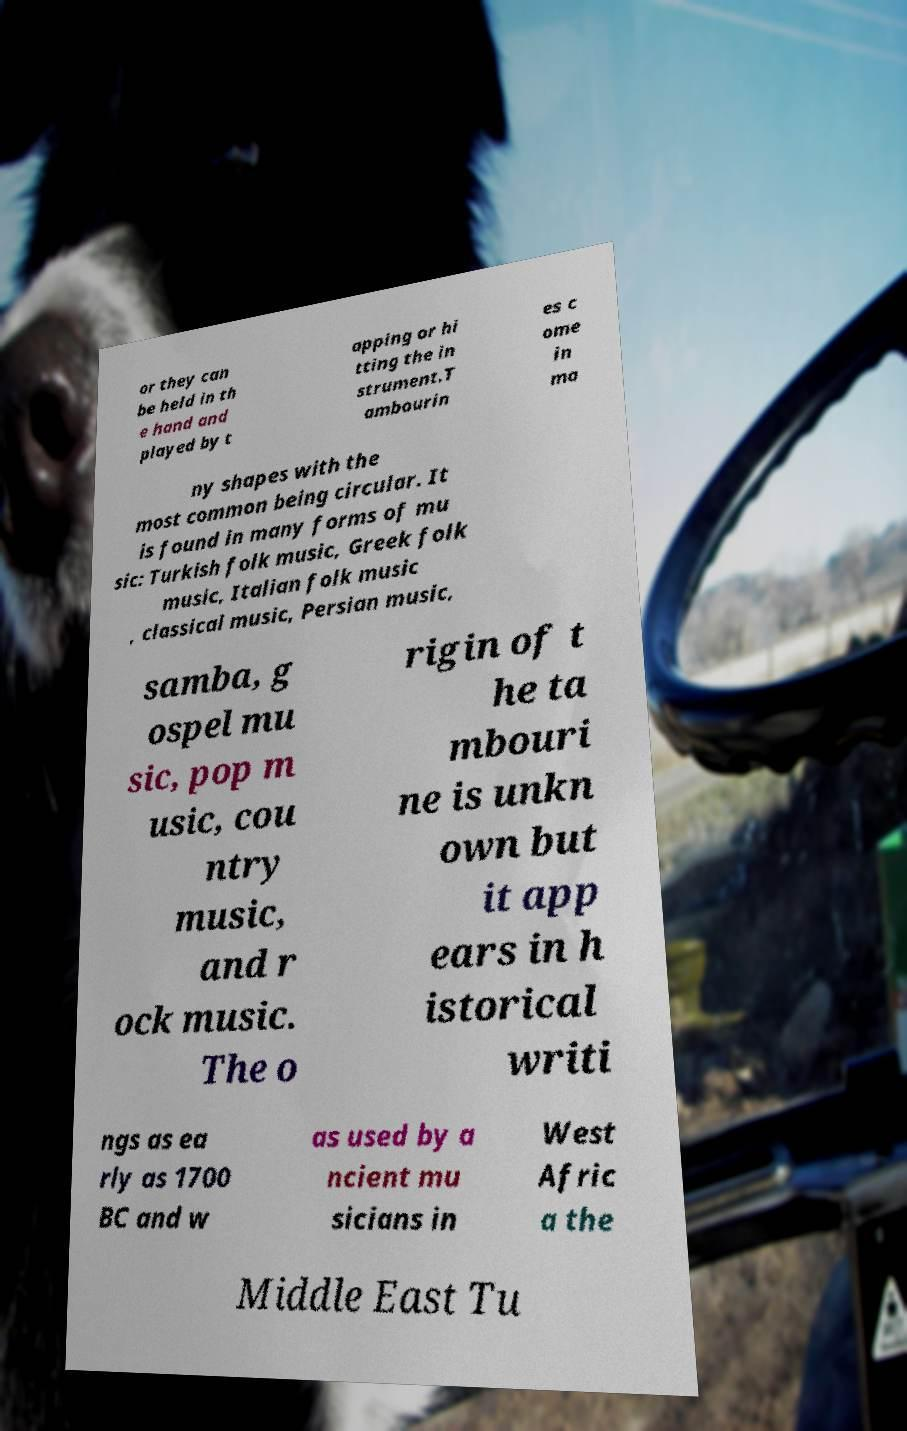Could you extract and type out the text from this image? or they can be held in th e hand and played by t apping or hi tting the in strument.T ambourin es c ome in ma ny shapes with the most common being circular. It is found in many forms of mu sic: Turkish folk music, Greek folk music, Italian folk music , classical music, Persian music, samba, g ospel mu sic, pop m usic, cou ntry music, and r ock music. The o rigin of t he ta mbouri ne is unkn own but it app ears in h istorical writi ngs as ea rly as 1700 BC and w as used by a ncient mu sicians in West Afric a the Middle East Tu 